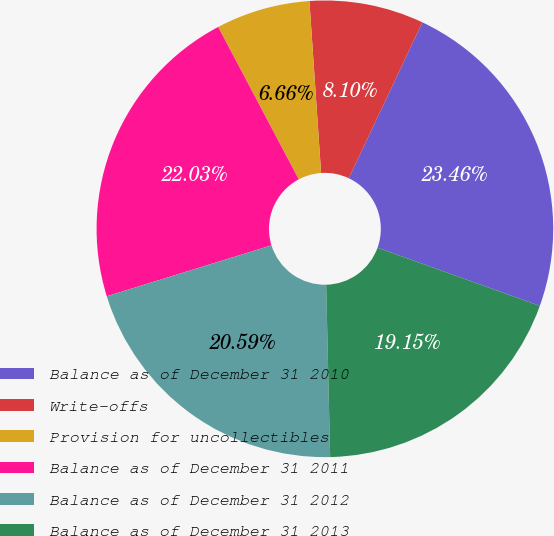Convert chart. <chart><loc_0><loc_0><loc_500><loc_500><pie_chart><fcel>Balance as of December 31 2010<fcel>Write-offs<fcel>Provision for uncollectibles<fcel>Balance as of December 31 2011<fcel>Balance as of December 31 2012<fcel>Balance as of December 31 2013<nl><fcel>23.46%<fcel>8.1%<fcel>6.66%<fcel>22.03%<fcel>20.59%<fcel>19.15%<nl></chart> 